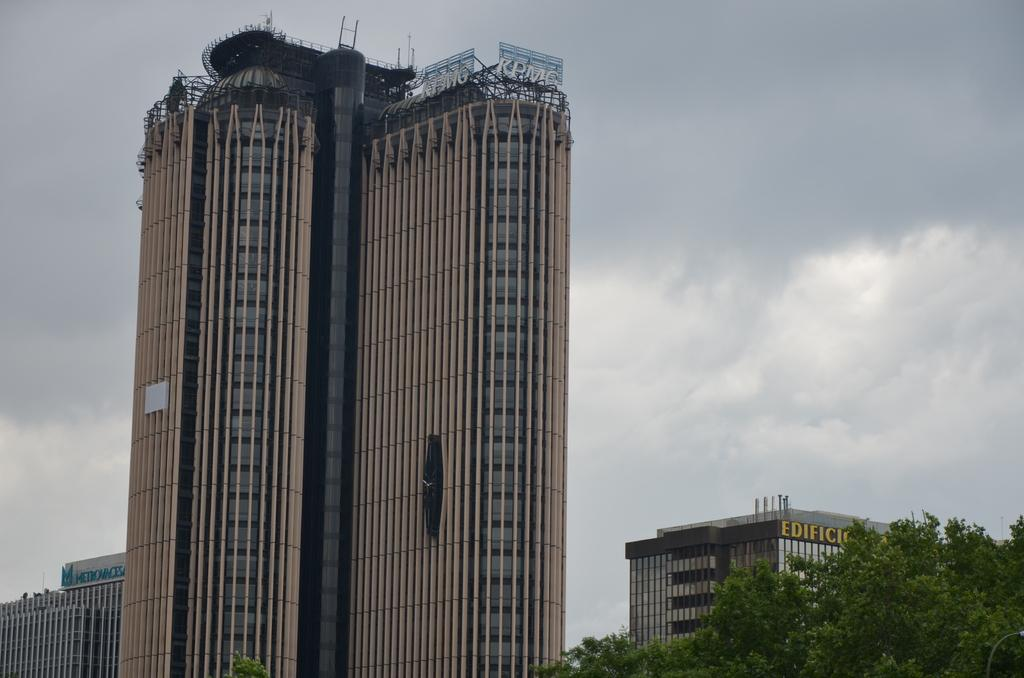What type of structures are present in the image? There are tall buildings with many floors in the image. What can be seen around the buildings? The buildings are surrounded by trees. How would you describe the sky in the image? The sky is cloudy in the image. What type of pest can be seen crawling on the buildings in the image? There are no pests visible in the image; it only shows tall buildings surrounded by trees and a cloudy sky. 